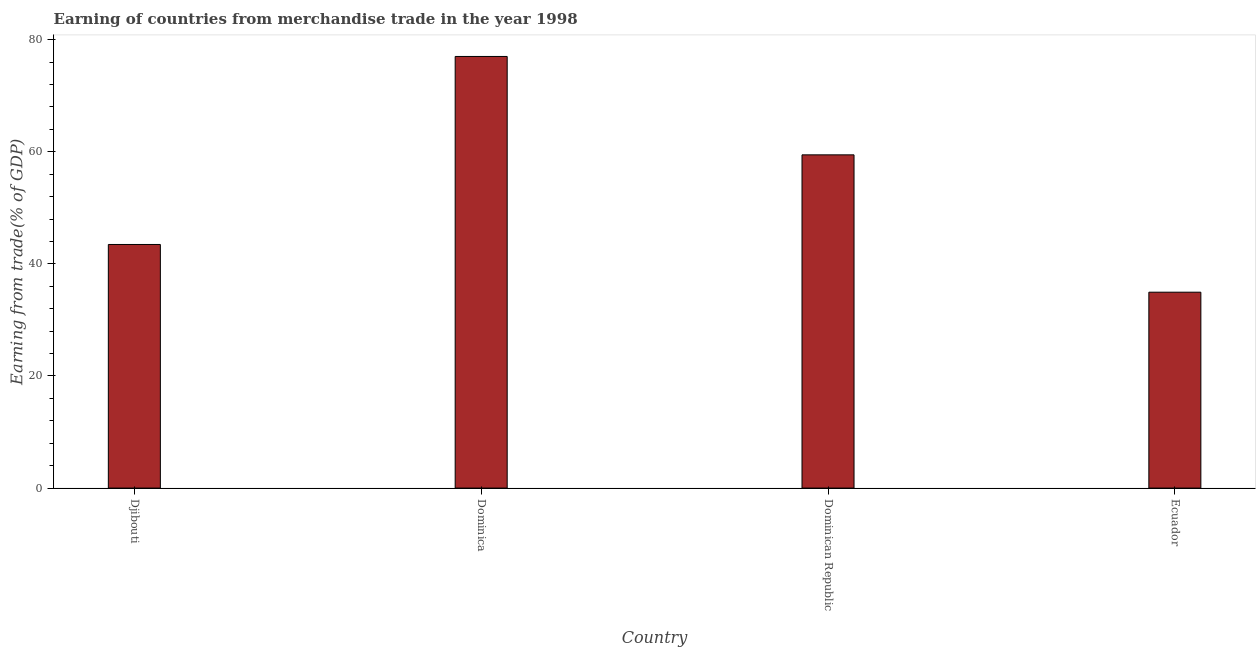What is the title of the graph?
Provide a short and direct response. Earning of countries from merchandise trade in the year 1998. What is the label or title of the X-axis?
Offer a terse response. Country. What is the label or title of the Y-axis?
Give a very brief answer. Earning from trade(% of GDP). What is the earning from merchandise trade in Dominican Republic?
Give a very brief answer. 59.45. Across all countries, what is the maximum earning from merchandise trade?
Provide a short and direct response. 77. Across all countries, what is the minimum earning from merchandise trade?
Offer a terse response. 34.95. In which country was the earning from merchandise trade maximum?
Your answer should be compact. Dominica. In which country was the earning from merchandise trade minimum?
Your answer should be compact. Ecuador. What is the sum of the earning from merchandise trade?
Offer a terse response. 214.86. What is the difference between the earning from merchandise trade in Djibouti and Dominica?
Ensure brevity in your answer.  -33.54. What is the average earning from merchandise trade per country?
Offer a very short reply. 53.71. What is the median earning from merchandise trade?
Provide a short and direct response. 51.45. In how many countries, is the earning from merchandise trade greater than 28 %?
Offer a very short reply. 4. What is the ratio of the earning from merchandise trade in Dominica to that in Ecuador?
Offer a very short reply. 2.2. Is the earning from merchandise trade in Dominica less than that in Dominican Republic?
Keep it short and to the point. No. Is the difference between the earning from merchandise trade in Djibouti and Dominica greater than the difference between any two countries?
Give a very brief answer. No. What is the difference between the highest and the second highest earning from merchandise trade?
Provide a short and direct response. 17.55. Is the sum of the earning from merchandise trade in Djibouti and Ecuador greater than the maximum earning from merchandise trade across all countries?
Give a very brief answer. Yes. What is the difference between the highest and the lowest earning from merchandise trade?
Give a very brief answer. 42.05. In how many countries, is the earning from merchandise trade greater than the average earning from merchandise trade taken over all countries?
Your response must be concise. 2. How many countries are there in the graph?
Provide a short and direct response. 4. What is the Earning from trade(% of GDP) of Djibouti?
Provide a succinct answer. 43.46. What is the Earning from trade(% of GDP) in Dominica?
Offer a very short reply. 77. What is the Earning from trade(% of GDP) of Dominican Republic?
Ensure brevity in your answer.  59.45. What is the Earning from trade(% of GDP) in Ecuador?
Your answer should be very brief. 34.95. What is the difference between the Earning from trade(% of GDP) in Djibouti and Dominica?
Ensure brevity in your answer.  -33.54. What is the difference between the Earning from trade(% of GDP) in Djibouti and Dominican Republic?
Make the answer very short. -15.99. What is the difference between the Earning from trade(% of GDP) in Djibouti and Ecuador?
Provide a succinct answer. 8.51. What is the difference between the Earning from trade(% of GDP) in Dominica and Dominican Republic?
Keep it short and to the point. 17.55. What is the difference between the Earning from trade(% of GDP) in Dominica and Ecuador?
Provide a short and direct response. 42.05. What is the difference between the Earning from trade(% of GDP) in Dominican Republic and Ecuador?
Give a very brief answer. 24.5. What is the ratio of the Earning from trade(% of GDP) in Djibouti to that in Dominica?
Give a very brief answer. 0.56. What is the ratio of the Earning from trade(% of GDP) in Djibouti to that in Dominican Republic?
Your answer should be compact. 0.73. What is the ratio of the Earning from trade(% of GDP) in Djibouti to that in Ecuador?
Provide a succinct answer. 1.24. What is the ratio of the Earning from trade(% of GDP) in Dominica to that in Dominican Republic?
Make the answer very short. 1.29. What is the ratio of the Earning from trade(% of GDP) in Dominica to that in Ecuador?
Provide a short and direct response. 2.2. What is the ratio of the Earning from trade(% of GDP) in Dominican Republic to that in Ecuador?
Keep it short and to the point. 1.7. 